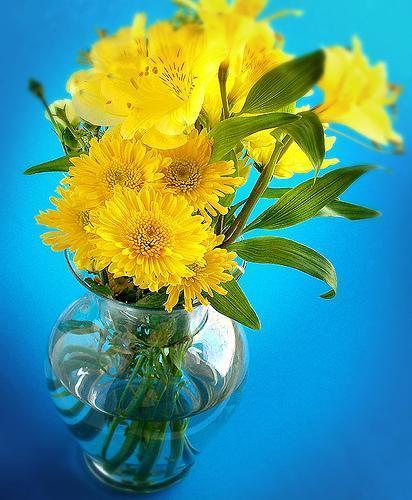How many vases are in the photo?
Give a very brief answer. 1. 